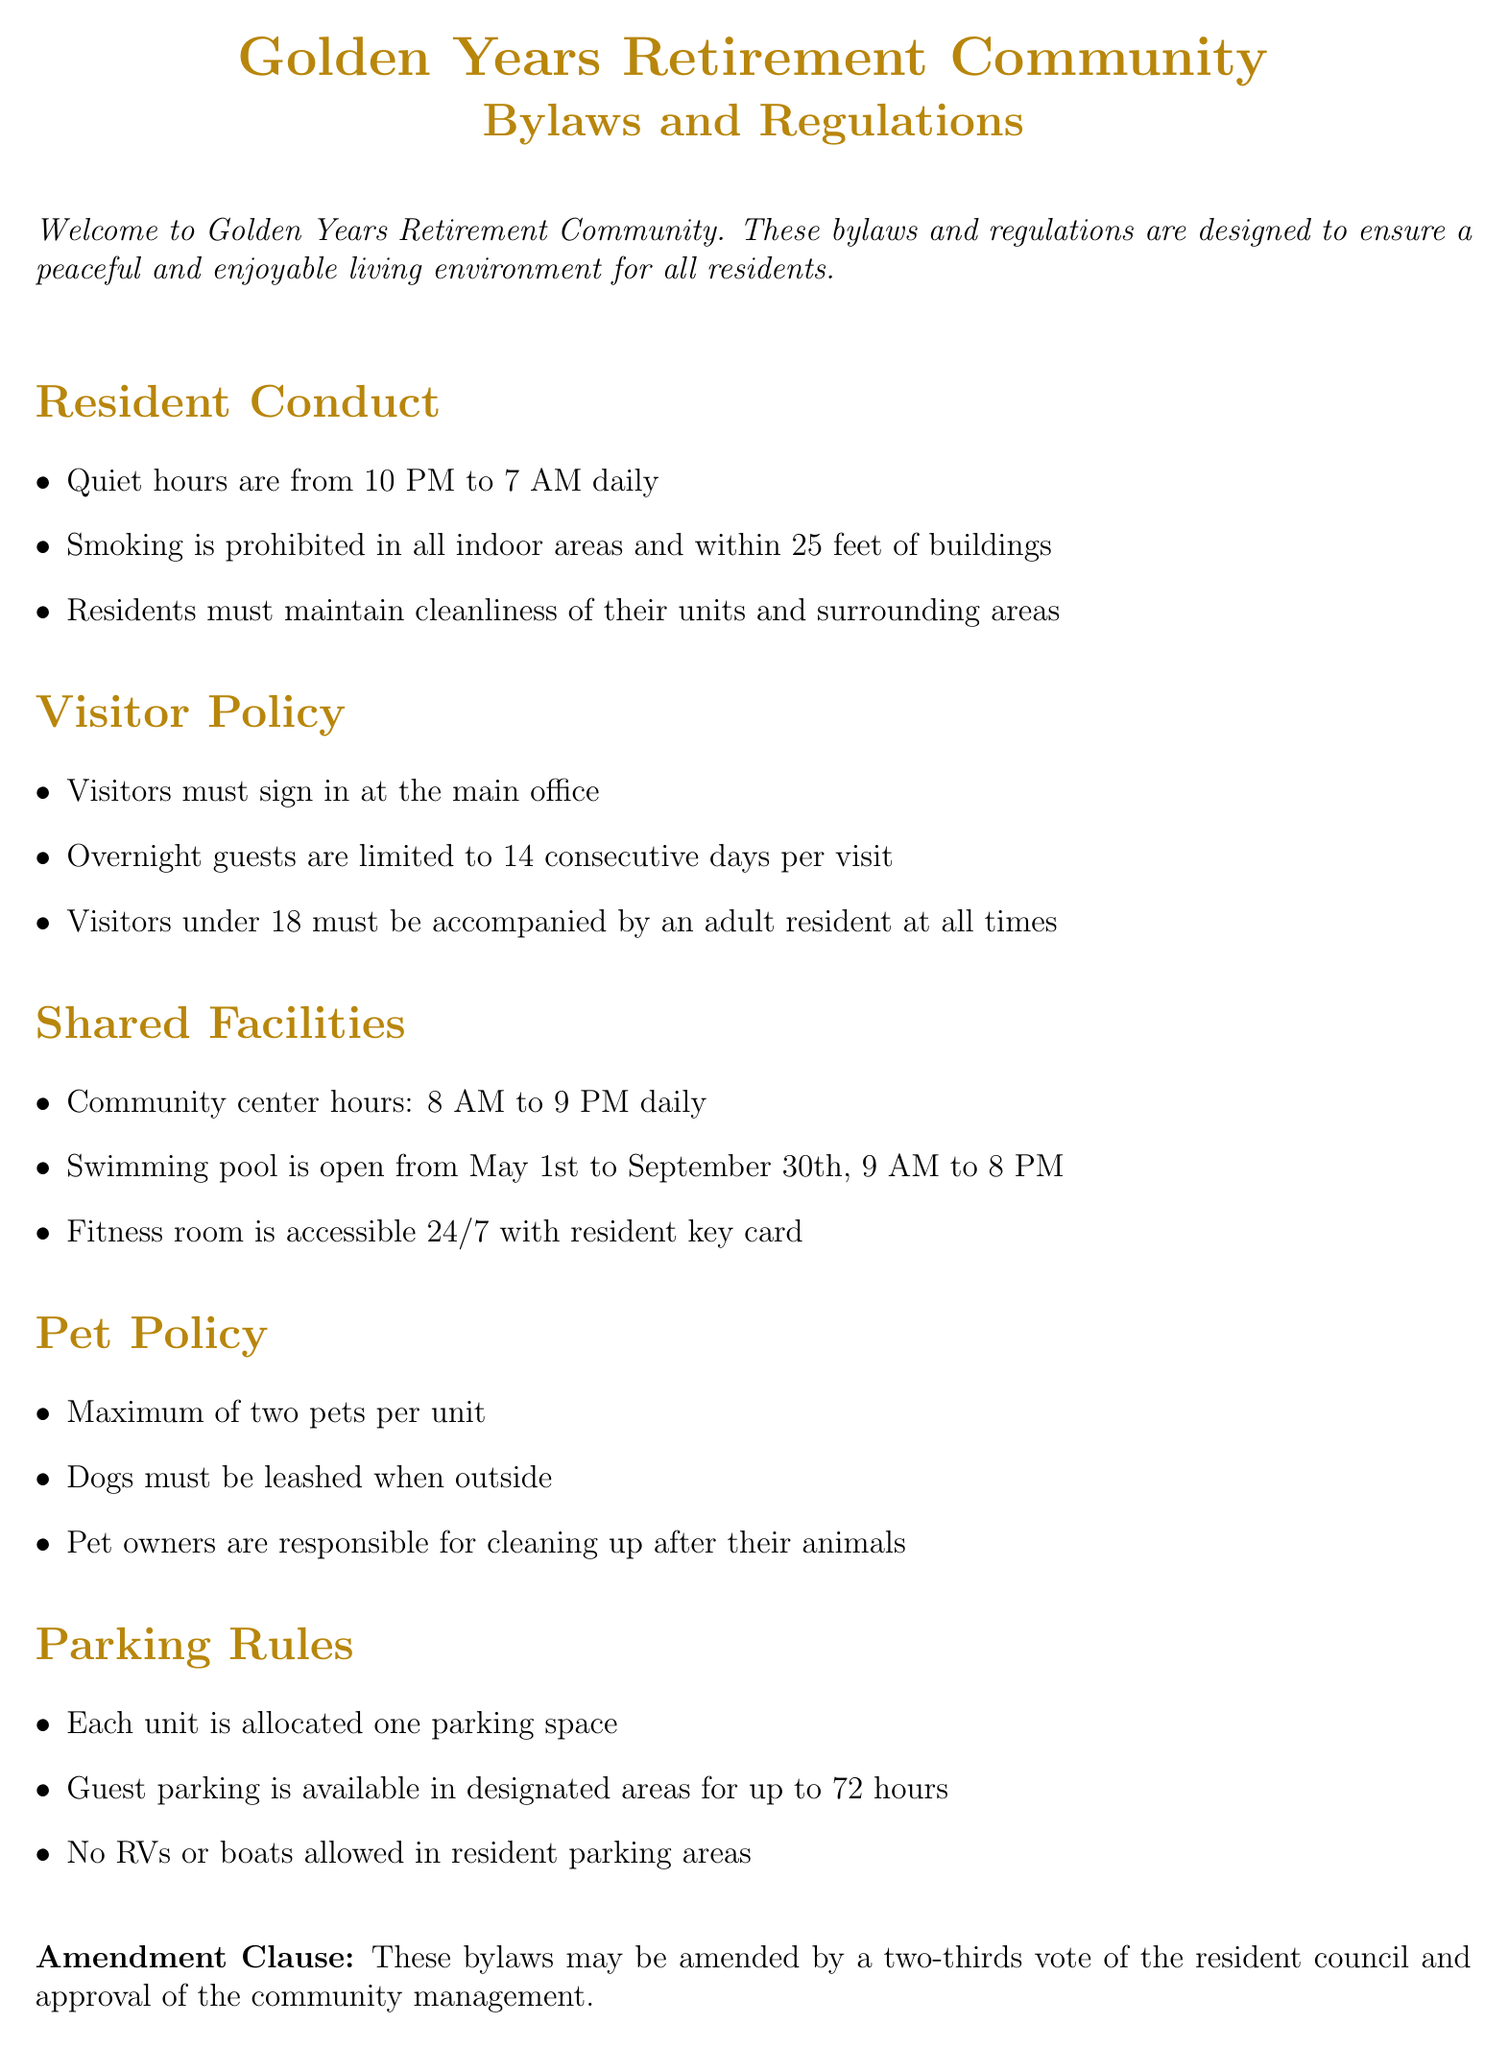What are the quiet hours? The quiet hours are specified as a time period during which noise should be minimized for residents' comfort, which is 10 PM to 7 AM daily.
Answer: 10 PM to 7 AM How many pets are allowed per unit? The pet policy delineates the maximum number of pets that each resident can have in their unit, which is two.
Answer: Two What is the maximum duration for overnight guests? The visitor policy explains the limitation placed on the duration of stays for overnight guests, which is 14 consecutive days.
Answer: 14 consecutive days What time does the community center open? The shared facilities section specifies the operating hours for the community center, which is 8 AM.
Answer: 8 AM How far from buildings is smoking prohibited? The regulations for smoking indicate the distance from buildings in which smoking is banned, which is 25 feet.
Answer: 25 feet What is required for visitors under 18? The visitor policy states the condition concerning young visitors, which is they must be accompanied by an adult resident at all times.
Answer: Accompanied by an adult resident What is the parking rule for RVs? The parking rules specify restrictions on certain types of vehicles in resident parking areas, indicating that RVs are prohibited.
Answer: No RVs What is the fitness room access condition? The sharing rules for facilities include the access criteria for the fitness room, which is available 24/7 with a resident key card.
Answer: 24/7 with resident key card 